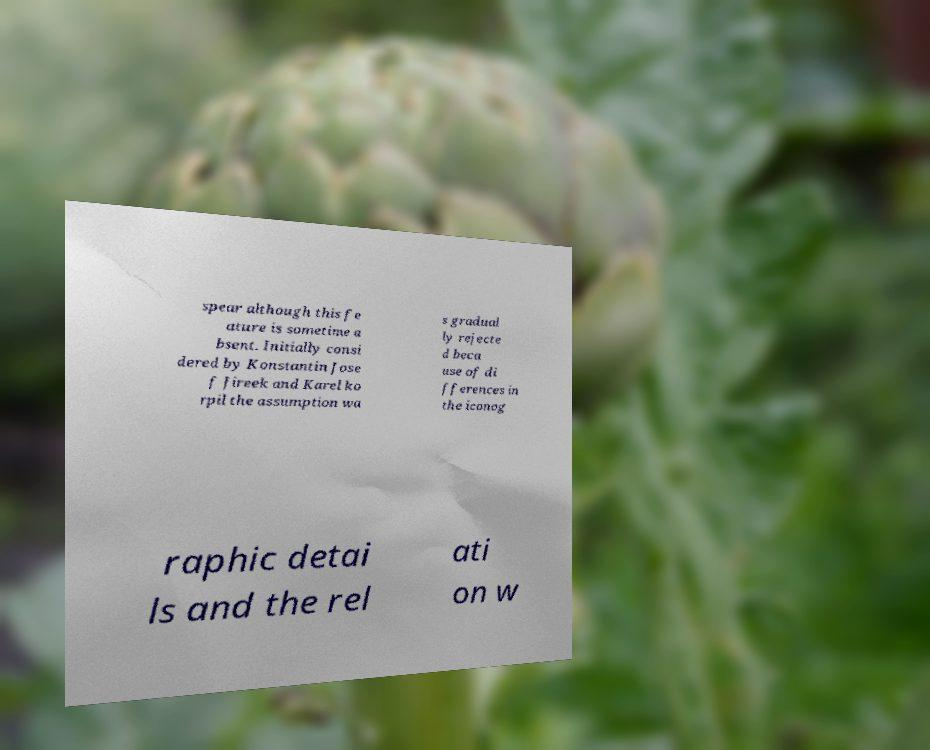For documentation purposes, I need the text within this image transcribed. Could you provide that? spear although this fe ature is sometime a bsent. Initially consi dered by Konstantin Jose f Jireek and Karel ko rpil the assumption wa s gradual ly rejecte d beca use of di fferences in the iconog raphic detai ls and the rel ati on w 